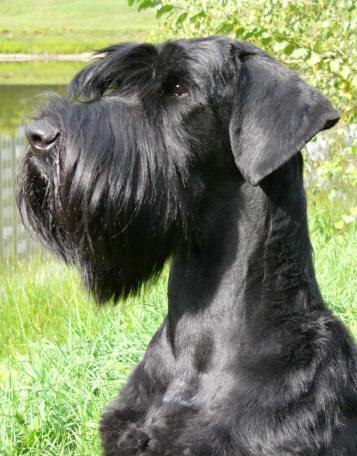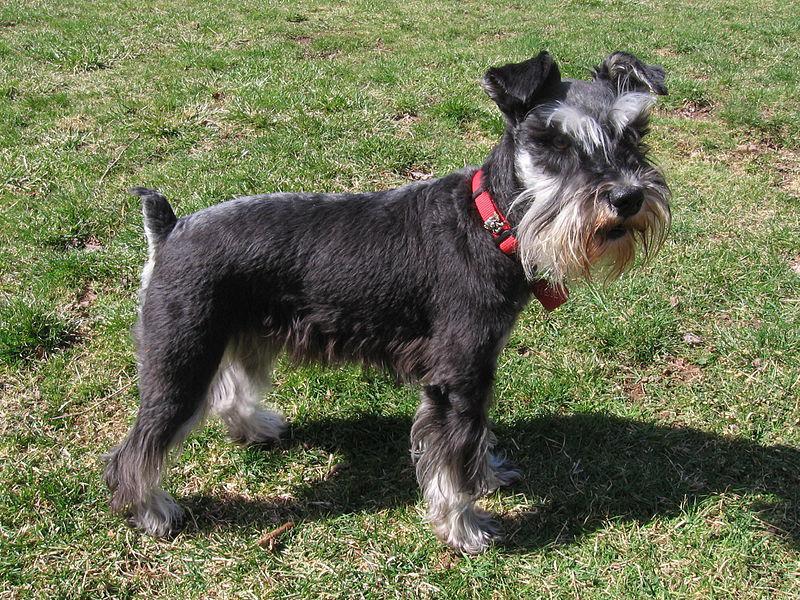The first image is the image on the left, the second image is the image on the right. Evaluate the accuracy of this statement regarding the images: "a dog is standing in the grass with a taught leash". Is it true? Answer yes or no. No. The first image is the image on the left, the second image is the image on the right. Analyze the images presented: Is the assertion "One of the two dogs is NOT on a leash." valid? Answer yes or no. No. 